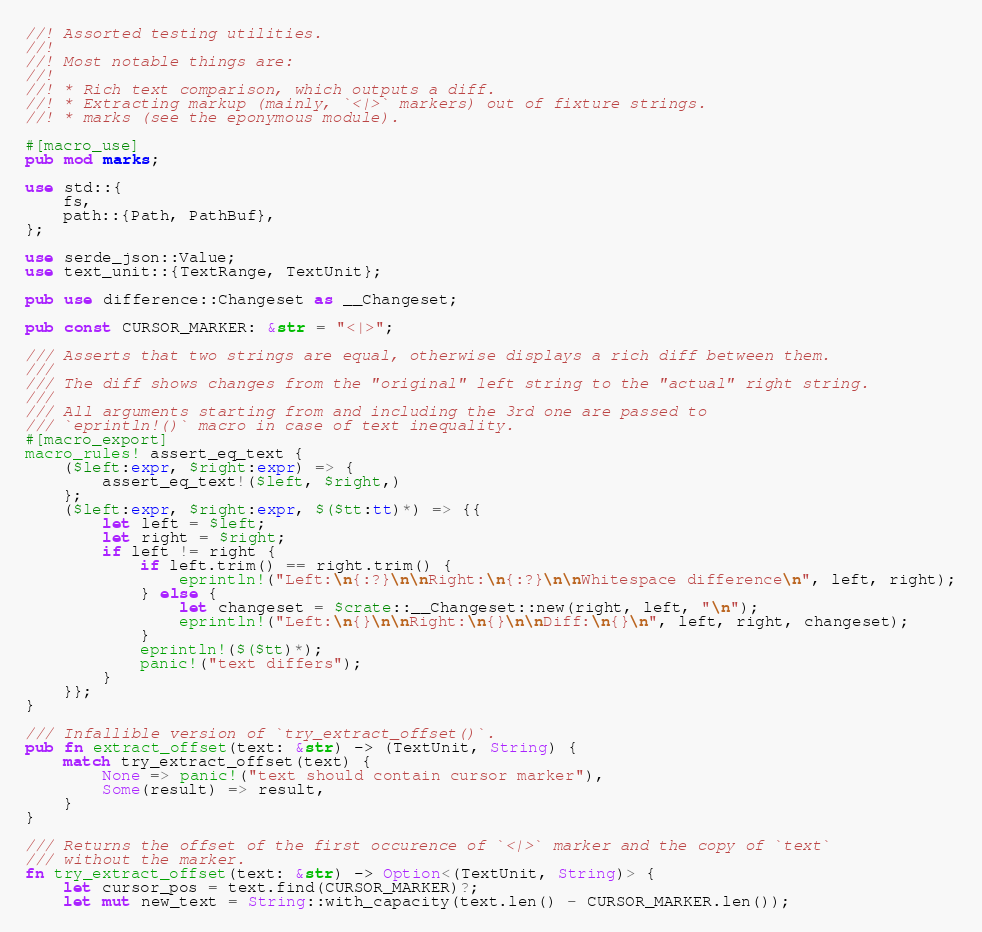Convert code to text. <code><loc_0><loc_0><loc_500><loc_500><_Rust_>//! Assorted testing utilities.
//!
//! Most notable things are:
//!
//! * Rich text comparison, which outputs a diff.
//! * Extracting markup (mainly, `<|>` markers) out of fixture strings.
//! * marks (see the eponymous module).

#[macro_use]
pub mod marks;

use std::{
    fs,
    path::{Path, PathBuf},
};

use serde_json::Value;
use text_unit::{TextRange, TextUnit};

pub use difference::Changeset as __Changeset;

pub const CURSOR_MARKER: &str = "<|>";

/// Asserts that two strings are equal, otherwise displays a rich diff between them.
///
/// The diff shows changes from the "original" left string to the "actual" right string.
///
/// All arguments starting from and including the 3rd one are passed to
/// `eprintln!()` macro in case of text inequality.
#[macro_export]
macro_rules! assert_eq_text {
    ($left:expr, $right:expr) => {
        assert_eq_text!($left, $right,)
    };
    ($left:expr, $right:expr, $($tt:tt)*) => {{
        let left = $left;
        let right = $right;
        if left != right {
            if left.trim() == right.trim() {
                eprintln!("Left:\n{:?}\n\nRight:\n{:?}\n\nWhitespace difference\n", left, right);
            } else {
                let changeset = $crate::__Changeset::new(right, left, "\n");
                eprintln!("Left:\n{}\n\nRight:\n{}\n\nDiff:\n{}\n", left, right, changeset);
            }
            eprintln!($($tt)*);
            panic!("text differs");
        }
    }};
}

/// Infallible version of `try_extract_offset()`.
pub fn extract_offset(text: &str) -> (TextUnit, String) {
    match try_extract_offset(text) {
        None => panic!("text should contain cursor marker"),
        Some(result) => result,
    }
}

/// Returns the offset of the first occurence of `<|>` marker and the copy of `text`
/// without the marker.
fn try_extract_offset(text: &str) -> Option<(TextUnit, String)> {
    let cursor_pos = text.find(CURSOR_MARKER)?;
    let mut new_text = String::with_capacity(text.len() - CURSOR_MARKER.len());</code> 